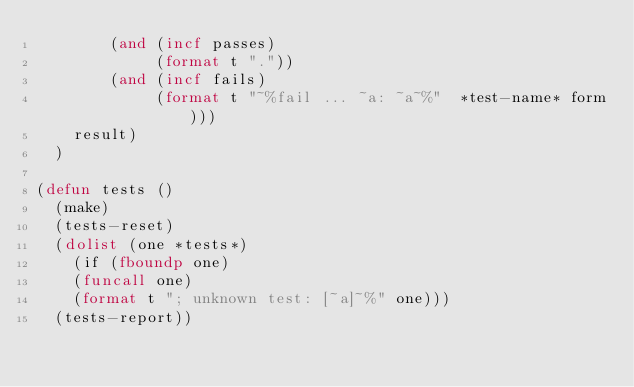<code> <loc_0><loc_0><loc_500><loc_500><_Lisp_>        (and (incf passes) 
             (format t "."))
        (and (incf fails) 
             (format t "~%fail ... ~a: ~a~%"  *test-name* form)))
    result)
  )

(defun tests ()
  (make) 
  (tests-reset) 
  (dolist (one *tests*)
    (if (fboundp one)
	(funcall one)
	(format t "; unknown test: [~a]~%" one)))
  (tests-report))
</code> 